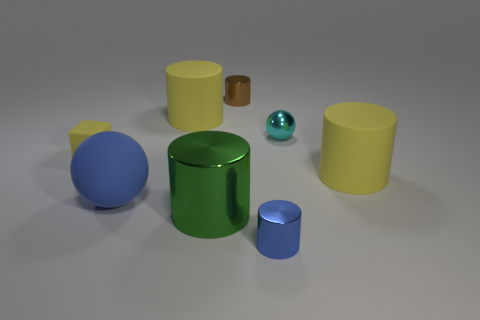What number of rubber cylinders are the same color as the rubber block?
Make the answer very short. 2. Does the sphere on the right side of the large blue sphere have the same material as the big blue object that is in front of the tiny shiny sphere?
Your response must be concise. No. There is a blue object that is to the left of the blue metal thing; what is its shape?
Your response must be concise. Sphere. What material is the large cylinder that is in front of the yellow matte object that is right of the cyan shiny sphere?
Ensure brevity in your answer.  Metal. Is the number of large green metal cylinders right of the large blue object greater than the number of big blue shiny cubes?
Keep it short and to the point. Yes. What number of other things are the same color as the tiny ball?
Your answer should be very brief. 0. What shape is the brown thing that is the same size as the yellow cube?
Offer a very short reply. Cylinder. What number of big yellow cylinders are on the left side of the tiny cylinder that is left of the tiny cylinder in front of the green metallic object?
Provide a short and direct response. 1. How many rubber objects are small blue cylinders or green objects?
Provide a succinct answer. 0. What color is the small shiny thing that is behind the big metal thing and in front of the brown thing?
Your answer should be very brief. Cyan. 